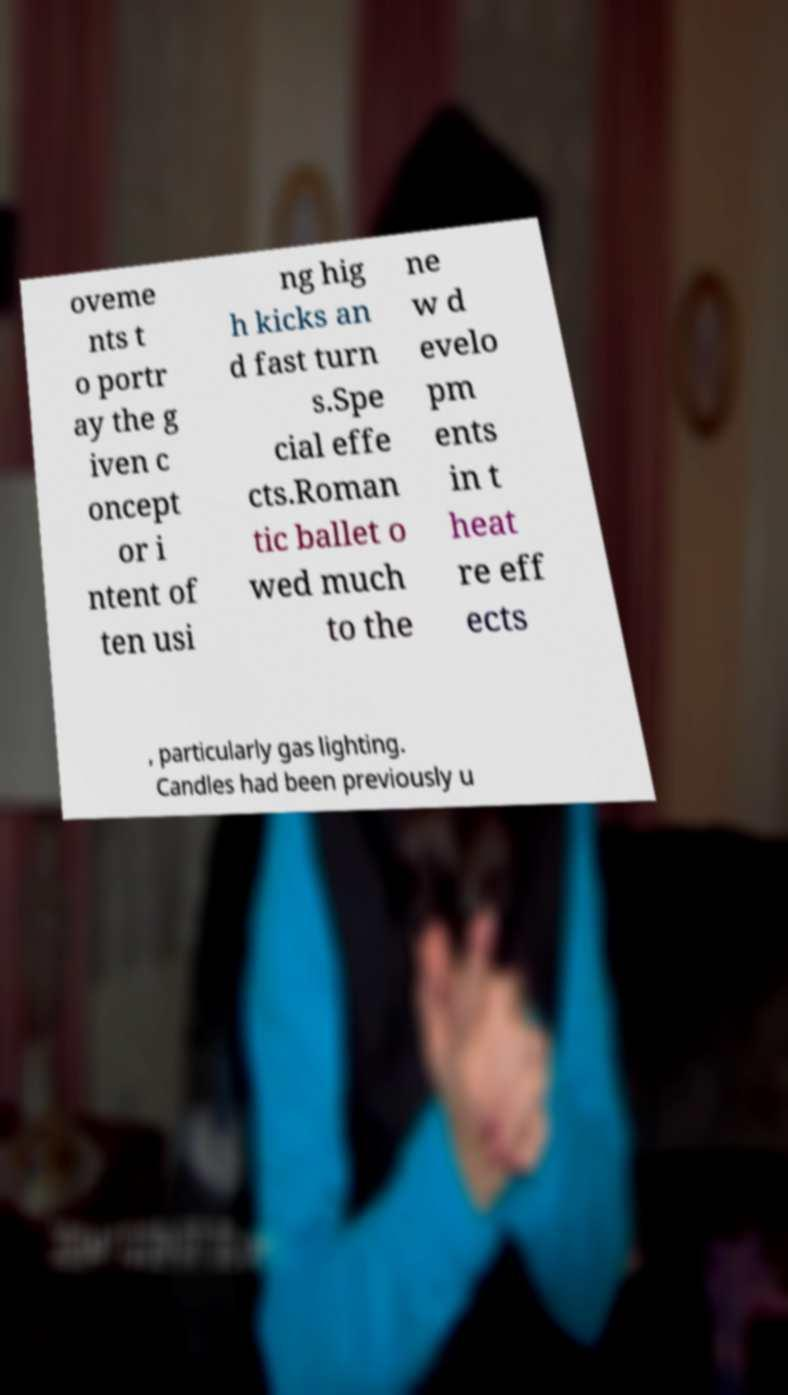I need the written content from this picture converted into text. Can you do that? oveme nts t o portr ay the g iven c oncept or i ntent of ten usi ng hig h kicks an d fast turn s.Spe cial effe cts.Roman tic ballet o wed much to the ne w d evelo pm ents in t heat re eff ects , particularly gas lighting. Candles had been previously u 